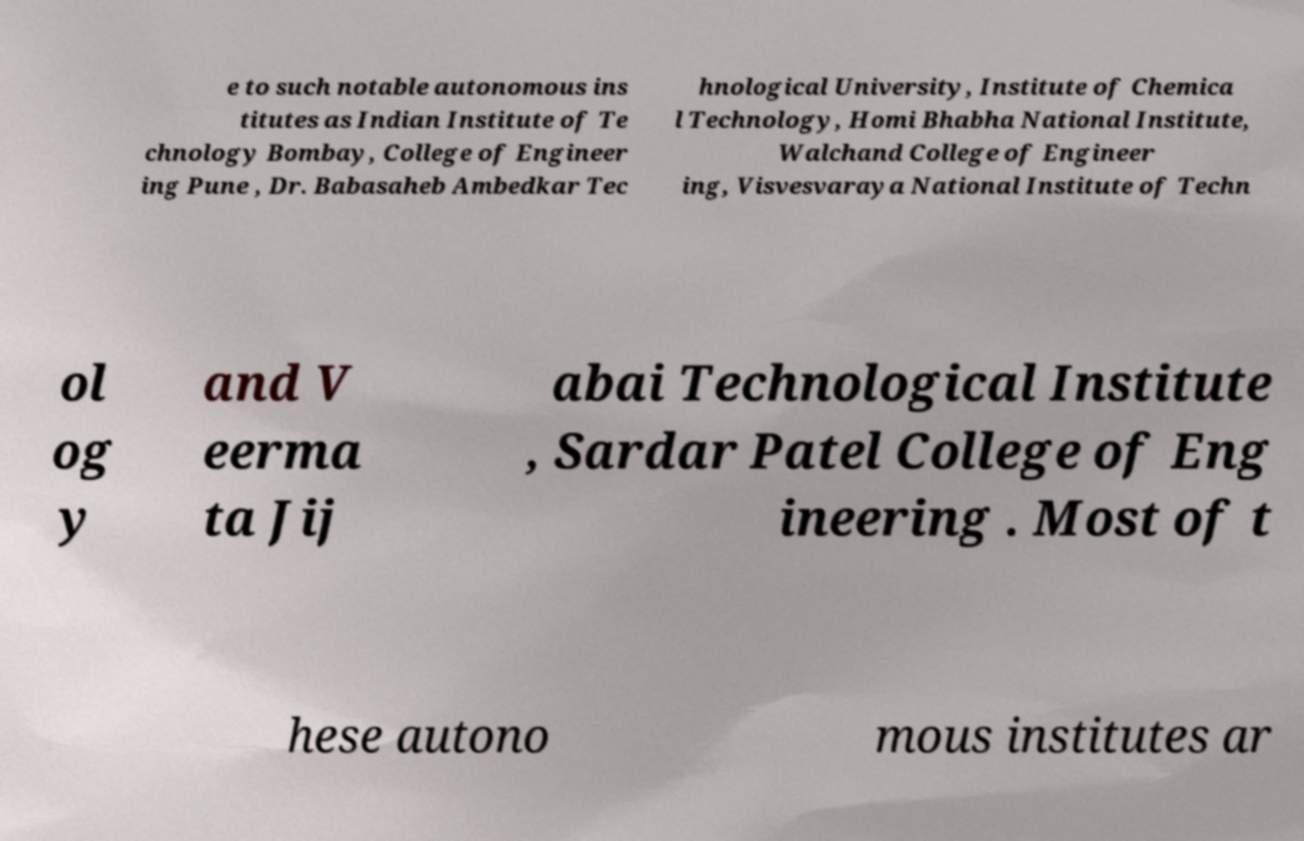I need the written content from this picture converted into text. Can you do that? e to such notable autonomous ins titutes as Indian Institute of Te chnology Bombay, College of Engineer ing Pune , Dr. Babasaheb Ambedkar Tec hnological University, Institute of Chemica l Technology, Homi Bhabha National Institute, Walchand College of Engineer ing, Visvesvaraya National Institute of Techn ol og y and V eerma ta Jij abai Technological Institute , Sardar Patel College of Eng ineering . Most of t hese autono mous institutes ar 